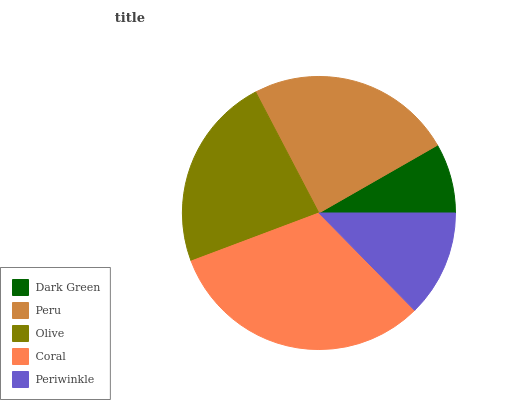Is Dark Green the minimum?
Answer yes or no. Yes. Is Coral the maximum?
Answer yes or no. Yes. Is Peru the minimum?
Answer yes or no. No. Is Peru the maximum?
Answer yes or no. No. Is Peru greater than Dark Green?
Answer yes or no. Yes. Is Dark Green less than Peru?
Answer yes or no. Yes. Is Dark Green greater than Peru?
Answer yes or no. No. Is Peru less than Dark Green?
Answer yes or no. No. Is Olive the high median?
Answer yes or no. Yes. Is Olive the low median?
Answer yes or no. Yes. Is Periwinkle the high median?
Answer yes or no. No. Is Dark Green the low median?
Answer yes or no. No. 